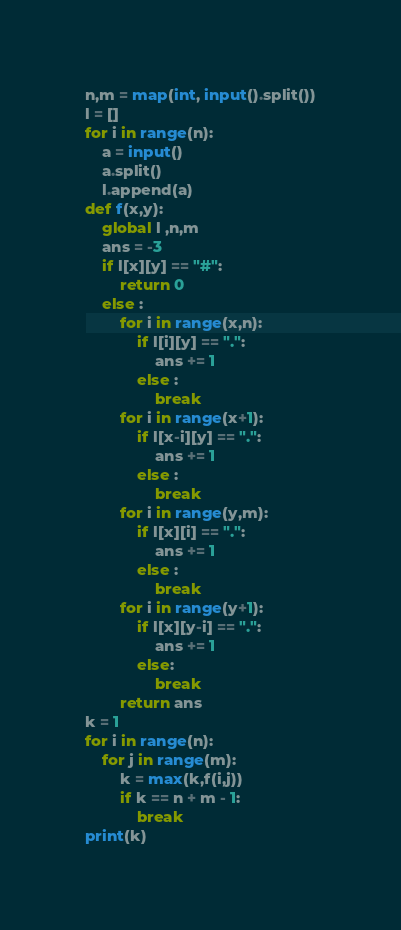<code> <loc_0><loc_0><loc_500><loc_500><_Python_>n,m = map(int, input().split())
l = []
for i in range(n):
    a = input()
    a.split()
    l.append(a)
def f(x,y):
    global l ,n,m
    ans = -3
    if l[x][y] == "#":
        return 0
    else :
        for i in range(x,n):
            if l[i][y] == ".":
                ans += 1
            else :
                break
        for i in range(x+1):
            if l[x-i][y] == ".":
                ans += 1
            else :
                break
        for i in range(y,m):
            if l[x][i] == ".":
                ans += 1
            else :
                break
        for i in range(y+1):
            if l[x][y-i] == ".":
                ans += 1
            else:
                break
        return ans
k = 1
for i in range(n):
    for j in range(m):
        k = max(k,f(i,j))
        if k == n + m - 1:
            break
print(k)
</code> 